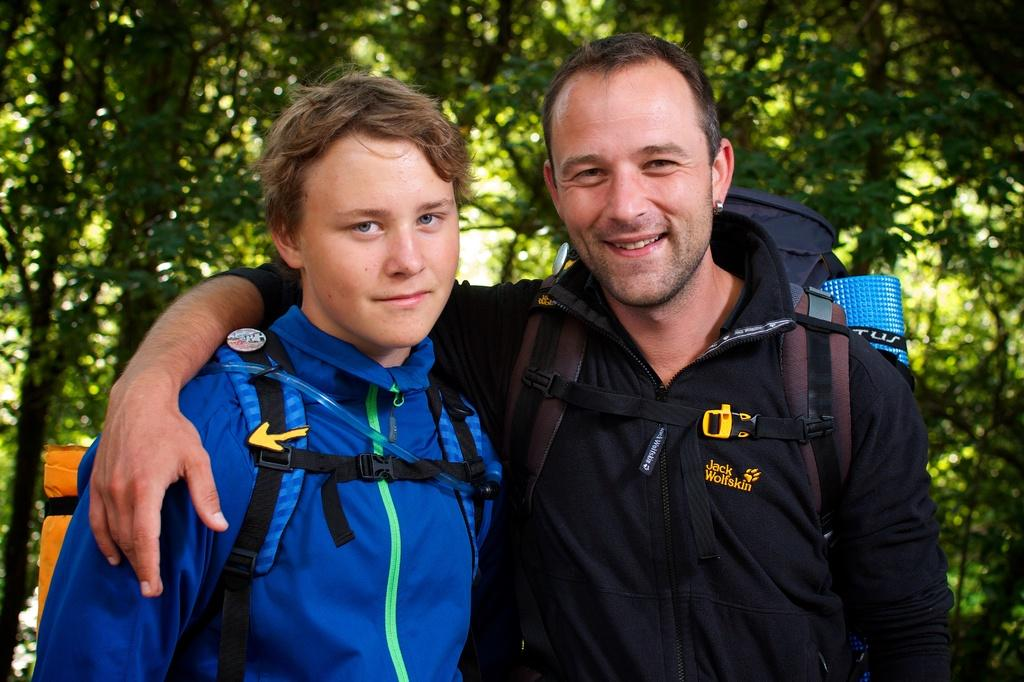How many people are in the image? There are two persons in the center of the image. What can be seen in the background of the image? There are trees in the background of the image. What type of nose can be seen on the visitor in the image? There is no visitor present in the image, and therefore no nose can be observed. 